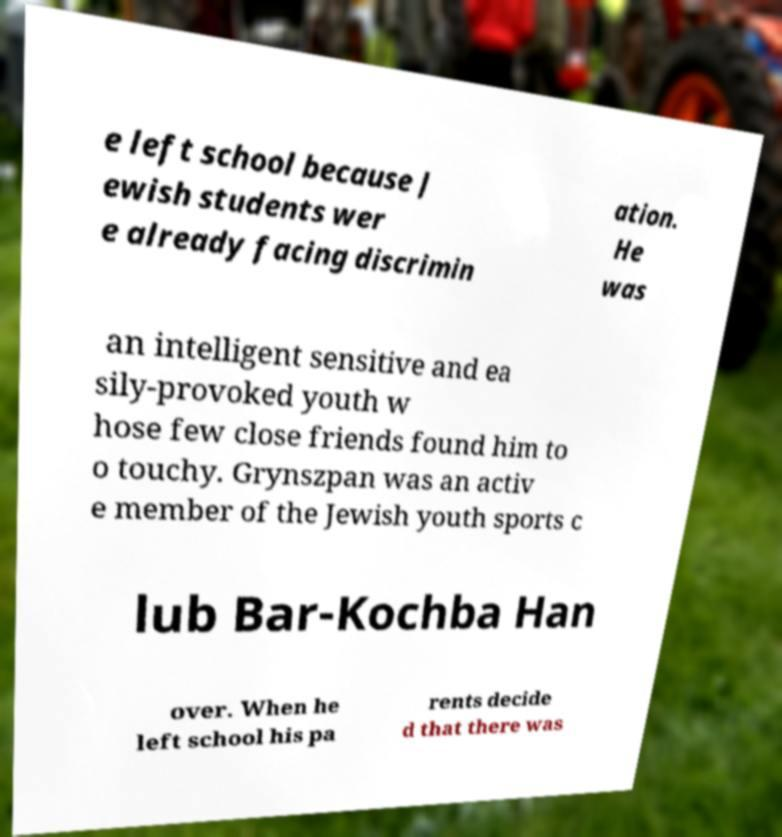Can you accurately transcribe the text from the provided image for me? e left school because J ewish students wer e already facing discrimin ation. He was an intelligent sensitive and ea sily-provoked youth w hose few close friends found him to o touchy. Grynszpan was an activ e member of the Jewish youth sports c lub Bar-Kochba Han over. When he left school his pa rents decide d that there was 